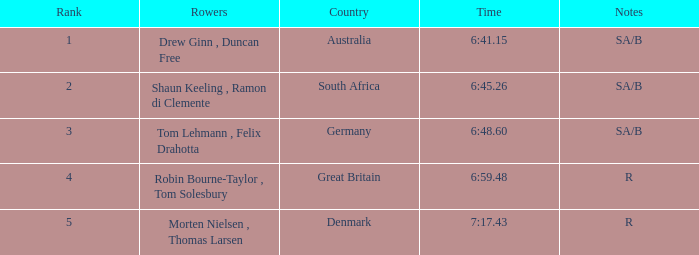What is the best ranking for rowers from denmark? 5.0. Could you parse the entire table as a dict? {'header': ['Rank', 'Rowers', 'Country', 'Time', 'Notes'], 'rows': [['1', 'Drew Ginn , Duncan Free', 'Australia', '6:41.15', 'SA/B'], ['2', 'Shaun Keeling , Ramon di Clemente', 'South Africa', '6:45.26', 'SA/B'], ['3', 'Tom Lehmann , Felix Drahotta', 'Germany', '6:48.60', 'SA/B'], ['4', 'Robin Bourne-Taylor , Tom Solesbury', 'Great Britain', '6:59.48', 'R'], ['5', 'Morten Nielsen , Thomas Larsen', 'Denmark', '7:17.43', 'R']]} 